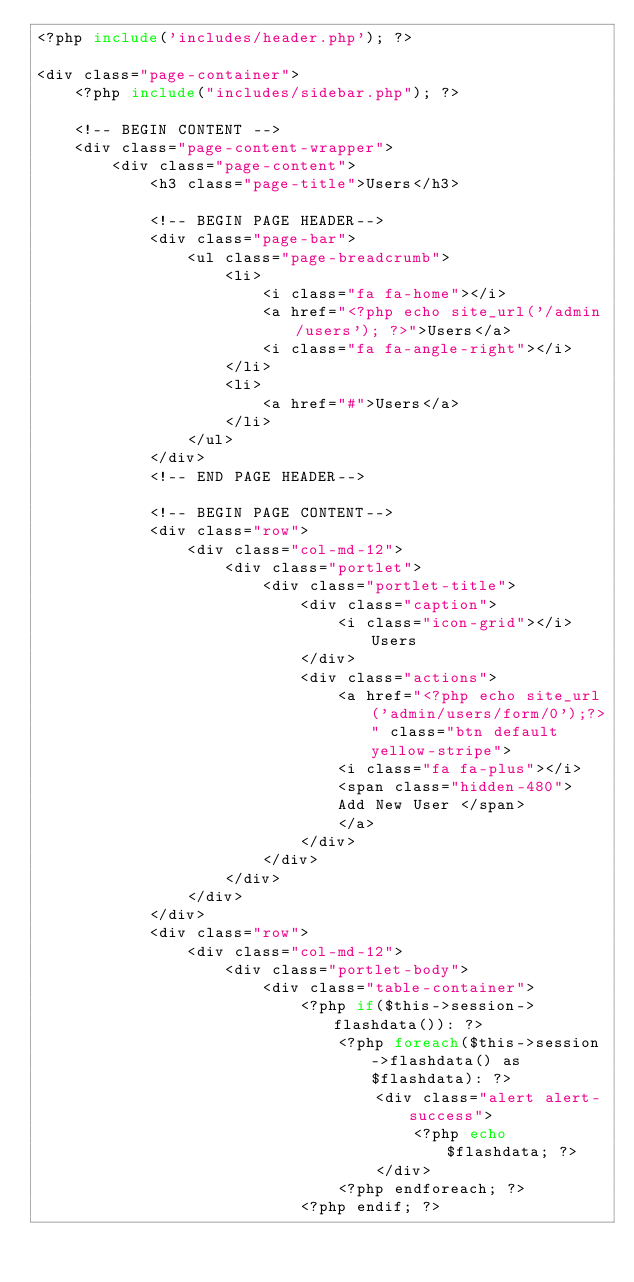Convert code to text. <code><loc_0><loc_0><loc_500><loc_500><_PHP_><?php include('includes/header.php'); ?>

<div class="page-container">
    <?php include("includes/sidebar.php"); ?>

    <!-- BEGIN CONTENT -->
    <div class="page-content-wrapper">
        <div class="page-content">
            <h3 class="page-title">Users</h3>

            <!-- BEGIN PAGE HEADER-->
            <div class="page-bar">
                <ul class="page-breadcrumb">
                    <li>
                        <i class="fa fa-home"></i>
                        <a href="<?php echo site_url('/admin/users'); ?>">Users</a>
                        <i class="fa fa-angle-right"></i>
                    </li>
                    <li>
                        <a href="#">Users</a>
                    </li>
                </ul>
            </div>
            <!-- END PAGE HEADER-->

            <!-- BEGIN PAGE CONTENT-->
            <div class="row">
                <div class="col-md-12">
                    <div class="portlet">
                        <div class="portlet-title">
                            <div class="caption">
                                <i class="icon-grid"></i>Users
                            </div> 
                            <div class="actions">
                                <a href="<?php echo site_url('admin/users/form/0');?>" class="btn default yellow-stripe">
                                <i class="fa fa-plus"></i>
                                <span class="hidden-480">
                                Add New User </span>
                                </a>                               
                            </div>                             
                        </div>
                    </div>
                </div>
            </div>
            <div class="row">
                <div class="col-md-12">
                    <div class="portlet-body">
                        <div class="table-container">
                            <?php if($this->session->flashdata()): ?>
                                <?php foreach($this->session->flashdata() as $flashdata): ?>
                                    <div class="alert alert-success">
                                        <?php echo $flashdata; ?>
                                    </div>
                                <?php endforeach; ?>
                            <?php endif; ?></code> 